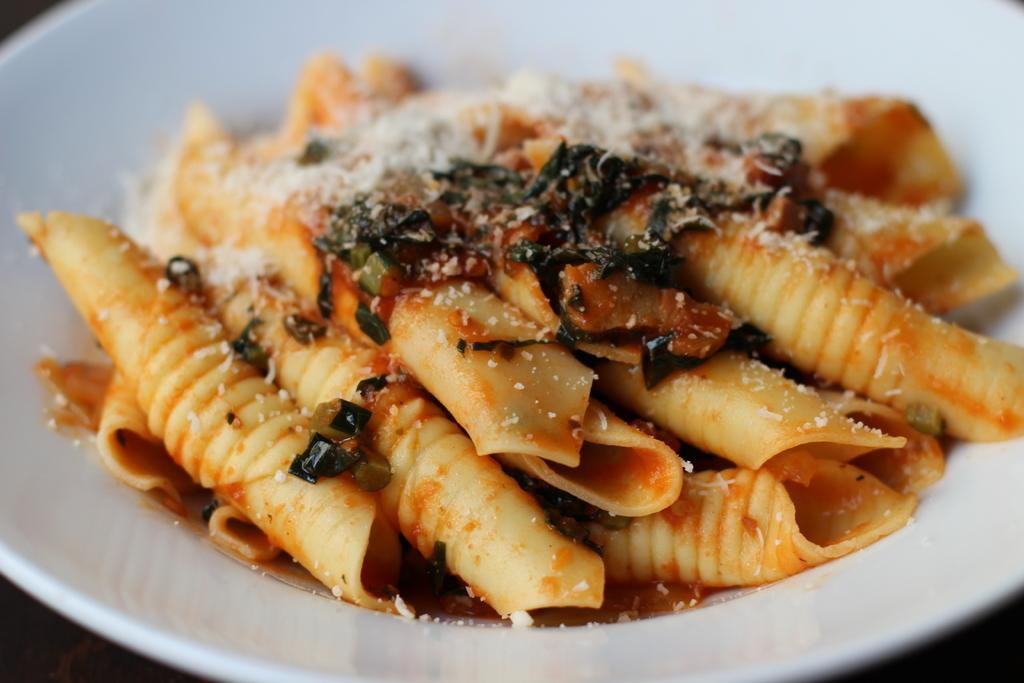What is on the plate that is visible in the image? There is pasta on the plate in the image. Is there anything else on the plate besides the pasta? Yes, there is garnish on the pasta. What type of sleet can be seen falling on the garden in the image? There is no sleet or garden present in the image; it features a plate with pasta and garnish. 